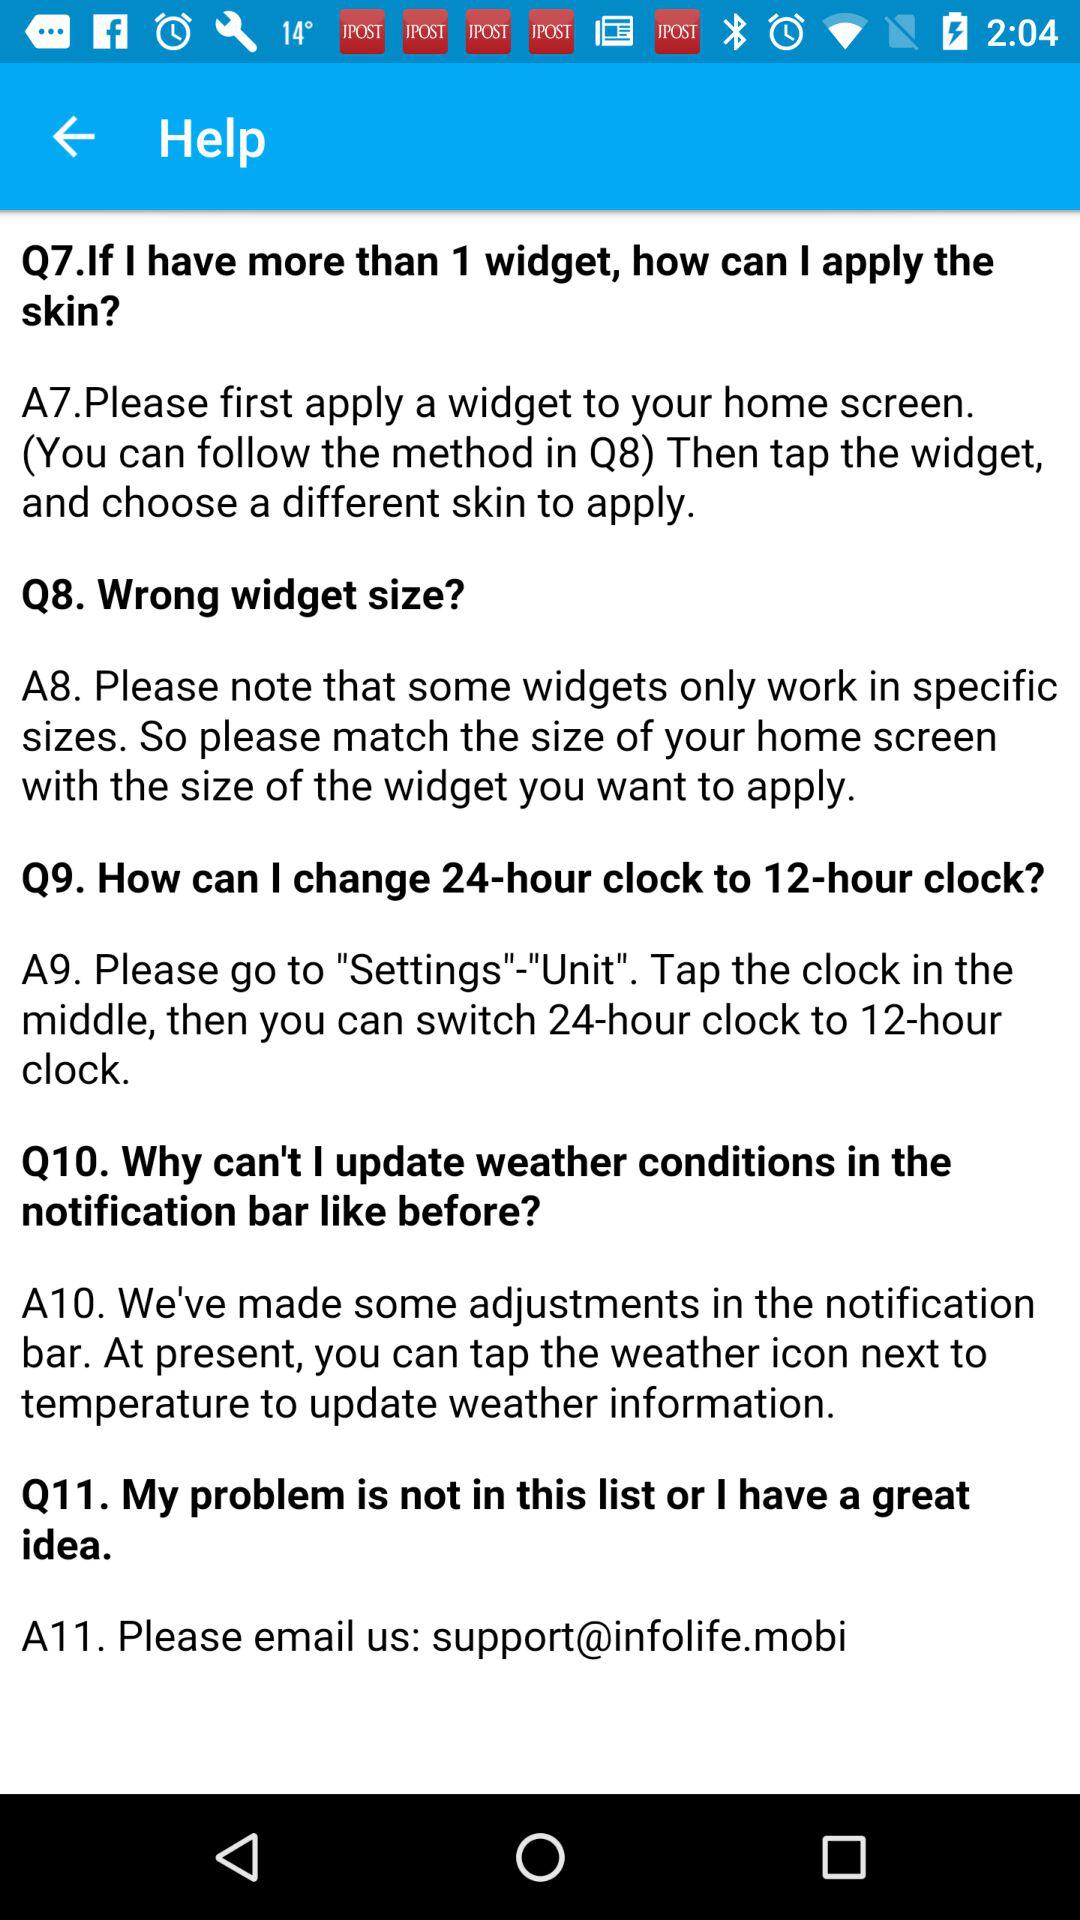How many questions are there in the help center?
Answer the question using a single word or phrase. 11 